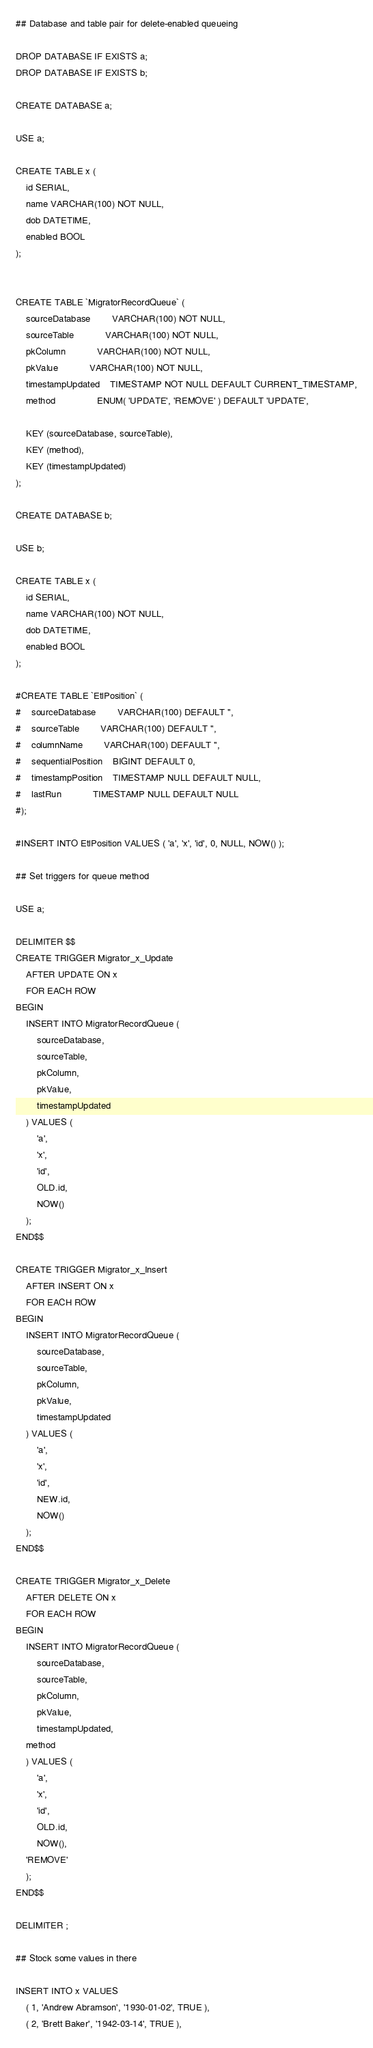Convert code to text. <code><loc_0><loc_0><loc_500><loc_500><_SQL_>## Database and table pair for delete-enabled queueing

DROP DATABASE IF EXISTS a;
DROP DATABASE IF EXISTS b;

CREATE DATABASE a;

USE a;

CREATE TABLE x (
	id SERIAL,
	name VARCHAR(100) NOT NULL,
	dob DATETIME,
	enabled BOOL
);


CREATE TABLE `MigratorRecordQueue` (
	sourceDatabase		VARCHAR(100) NOT NULL,
	sourceTable			VARCHAR(100) NOT NULL,
	pkColumn 			VARCHAR(100) NOT NULL,
	pkValue 			VARCHAR(100) NOT NULL,
	timestampUpdated 	TIMESTAMP NOT NULL DEFAULT CURRENT_TIMESTAMP,
	method 				ENUM( 'UPDATE', 'REMOVE' ) DEFAULT 'UPDATE',

	KEY (sourceDatabase, sourceTable),
	KEY (method),
	KEY (timestampUpdated)
);

CREATE DATABASE b;

USE b;

CREATE TABLE x (
	id SERIAL,
	name VARCHAR(100) NOT NULL,
	dob DATETIME,
	enabled BOOL
);

#CREATE TABLE `EtlPosition` (
#	sourceDatabase		VARCHAR(100) DEFAULT '',
#	sourceTable		VARCHAR(100) DEFAULT '',
#	columnName		VARCHAR(100) DEFAULT '',
#	sequentialPosition	BIGINT DEFAULT 0,
#	timestampPosition	TIMESTAMP NULL DEFAULT NULL,
#	lastRun			TIMESTAMP NULL DEFAULT NULL
#);

#INSERT INTO EtlPosition VALUES ( 'a', 'x', 'id', 0, NULL, NOW() );

## Set triggers for queue method

USE a;

DELIMITER $$
CREATE TRIGGER Migrator_x_Update
    AFTER UPDATE ON x
    FOR EACH ROW
BEGIN
    INSERT INTO MigratorRecordQueue (
        sourceDatabase,
        sourceTable,
        pkColumn,
        pkValue,
        timestampUpdated
    ) VALUES (
        'a',
        'x',
        'id',
        OLD.id,
        NOW()
    );
END$$

CREATE TRIGGER Migrator_x_Insert
    AFTER INSERT ON x
    FOR EACH ROW
BEGIN
    INSERT INTO MigratorRecordQueue (
        sourceDatabase,
        sourceTable,
        pkColumn,
        pkValue,
        timestampUpdated
    ) VALUES (
        'a',
        'x',
        'id',
        NEW.id,
        NOW()
    );
END$$

CREATE TRIGGER Migrator_x_Delete
    AFTER DELETE ON x
    FOR EACH ROW
BEGIN
    INSERT INTO MigratorRecordQueue (
        sourceDatabase,
        sourceTable,
        pkColumn,
        pkValue,
        timestampUpdated,
	method
    ) VALUES (
        'a',
        'x',
        'id',
        OLD.id,
        NOW(),
	'REMOVE'
    );
END$$

DELIMITER ;

## Stock some values in there

INSERT INTO x VALUES
	( 1, 'Andrew Abramson', '1930-01-02', TRUE ),
	( 2, 'Brett Baker', '1942-03-14', TRUE ),</code> 